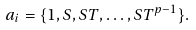<formula> <loc_0><loc_0><loc_500><loc_500>a _ { i } = \{ 1 , S , S T , \dots , S T ^ { p - 1 } \} .</formula> 